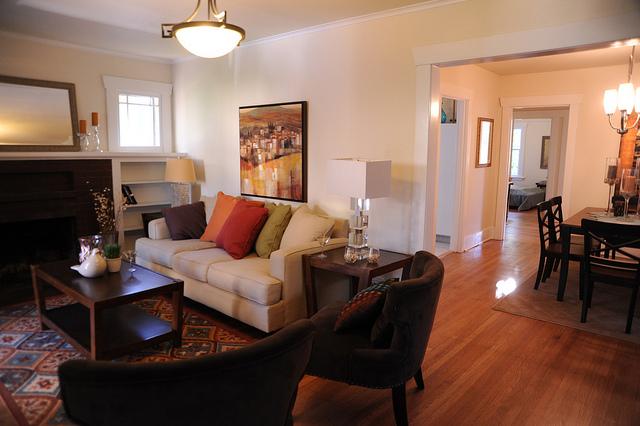Is this a hotel?
Give a very brief answer. No. What objects are under the lamp?
Short answer required. Table. What color are the chairs?
Be succinct. Brown. Is the light on?
Quick response, please. Yes. Is there a television?
Keep it brief. No. How many chairs are pictured at the table?
Concise answer only. 3. Does this room look clean?
Give a very brief answer. Yes. How many different colors are the cushions on the couch?
Concise answer only. 5. 